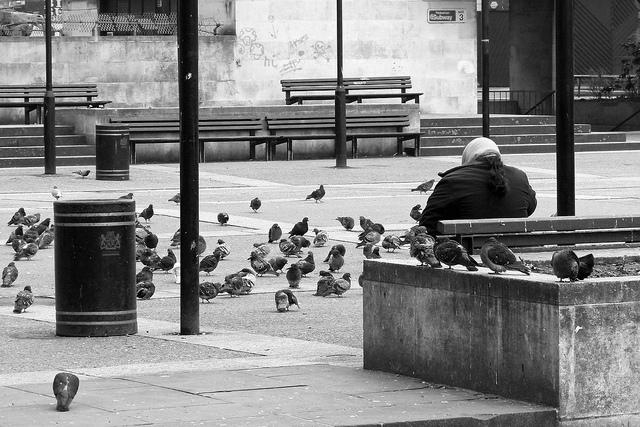Why are all the pigeons around the woman?

Choices:
A) like her
B) coincidence
C) feeding them
D) trained pigeons feeding them 